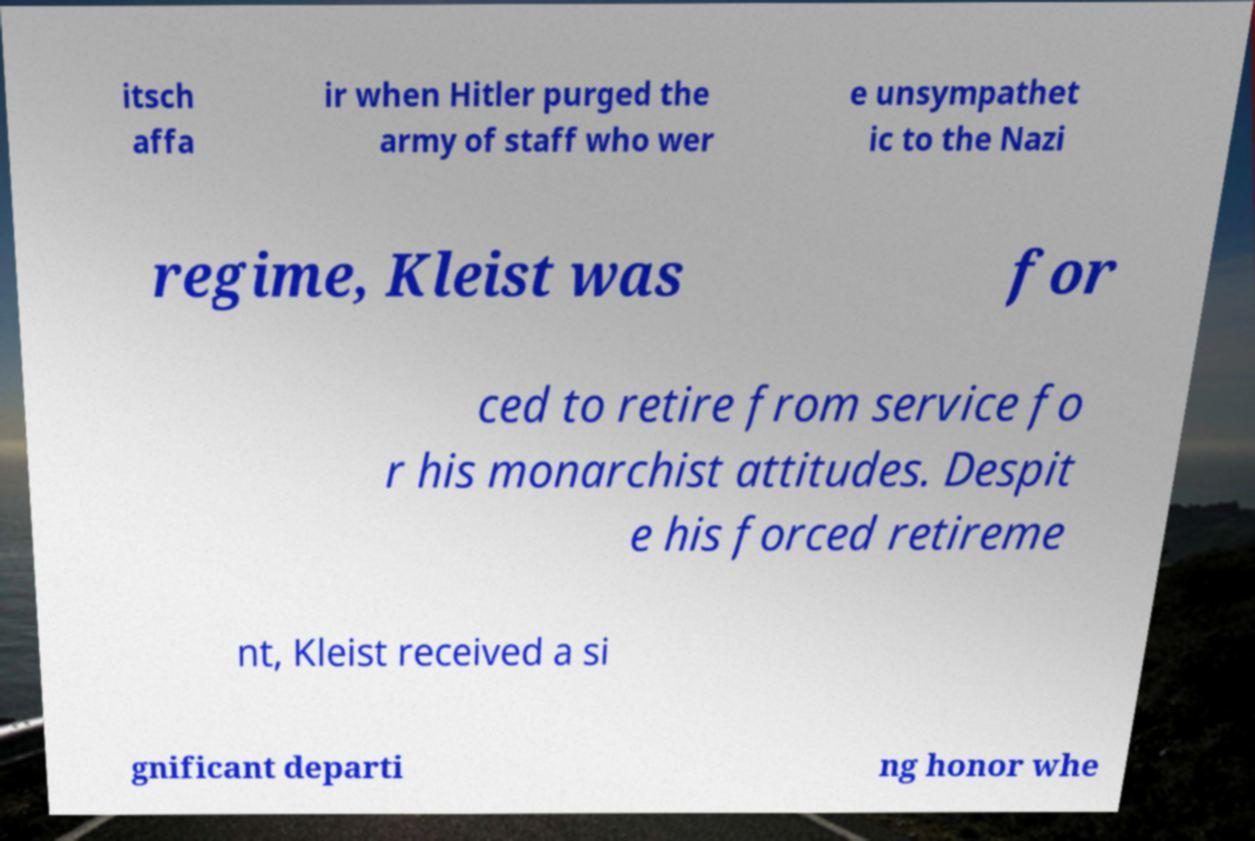Could you extract and type out the text from this image? itsch affa ir when Hitler purged the army of staff who wer e unsympathet ic to the Nazi regime, Kleist was for ced to retire from service fo r his monarchist attitudes. Despit e his forced retireme nt, Kleist received a si gnificant departi ng honor whe 